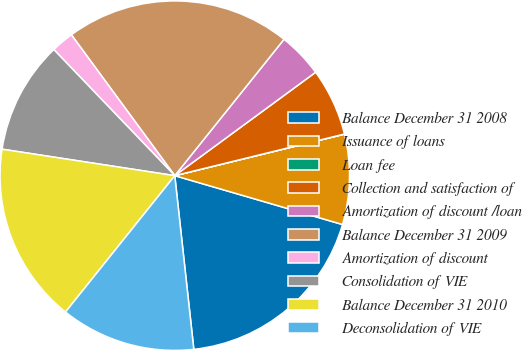Convert chart to OTSL. <chart><loc_0><loc_0><loc_500><loc_500><pie_chart><fcel>Balance December 31 2008<fcel>Issuance of loans<fcel>Loan fee<fcel>Collection and satisfaction of<fcel>Amortization of discount /loan<fcel>Balance December 31 2009<fcel>Amortization of discount<fcel>Consolidation of VIE<fcel>Balance December 31 2010<fcel>Deconsolidation of VIE<nl><fcel>18.75%<fcel>8.33%<fcel>0.01%<fcel>6.25%<fcel>4.17%<fcel>20.83%<fcel>2.09%<fcel>10.41%<fcel>16.67%<fcel>12.49%<nl></chart> 